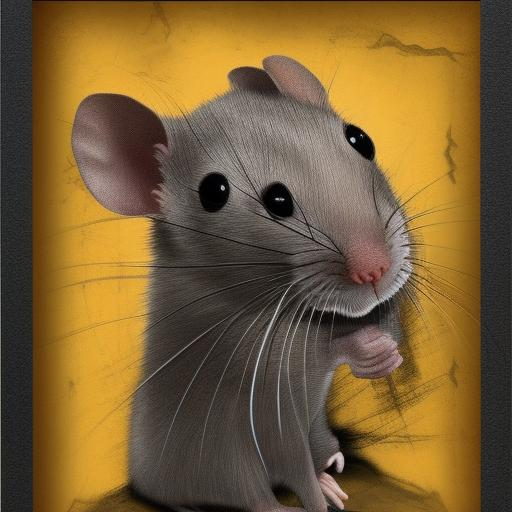Can you describe the artistic style used in this image? The artistic style of this image resembles digital painting with a touch of realism, particularly in the way textures and lighting are used. The fur of the mouse is rendered with great detail, which emphasizes the realism, while the smooth background with a simple, cracked texture provides a stylized contrast. How does the use of color influence the image's impact? The predominance of yellow in the background draws attention immediately, invoking a sense of warmth but also caution, as yellow can symbolize both. The realistic grey tones of the mouse stand out against this backdrop, highlighting the main subject effectively and adding depth to the composition. 